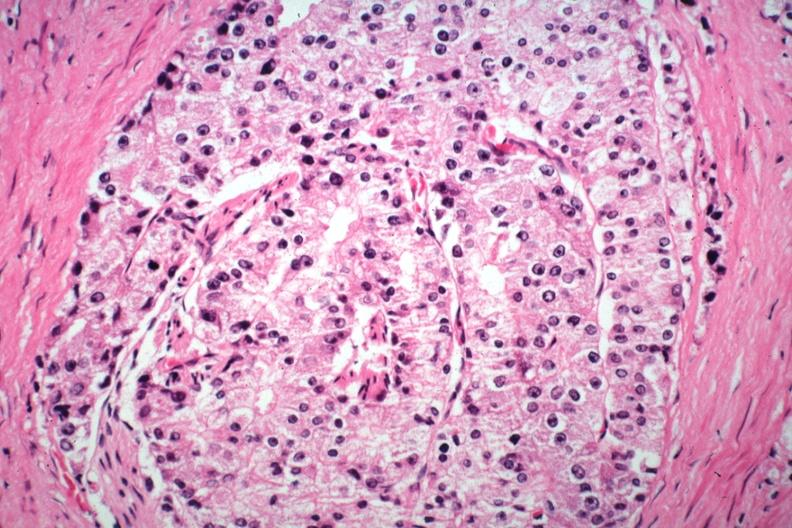s prostate present?
Answer the question using a single word or phrase. Yes 